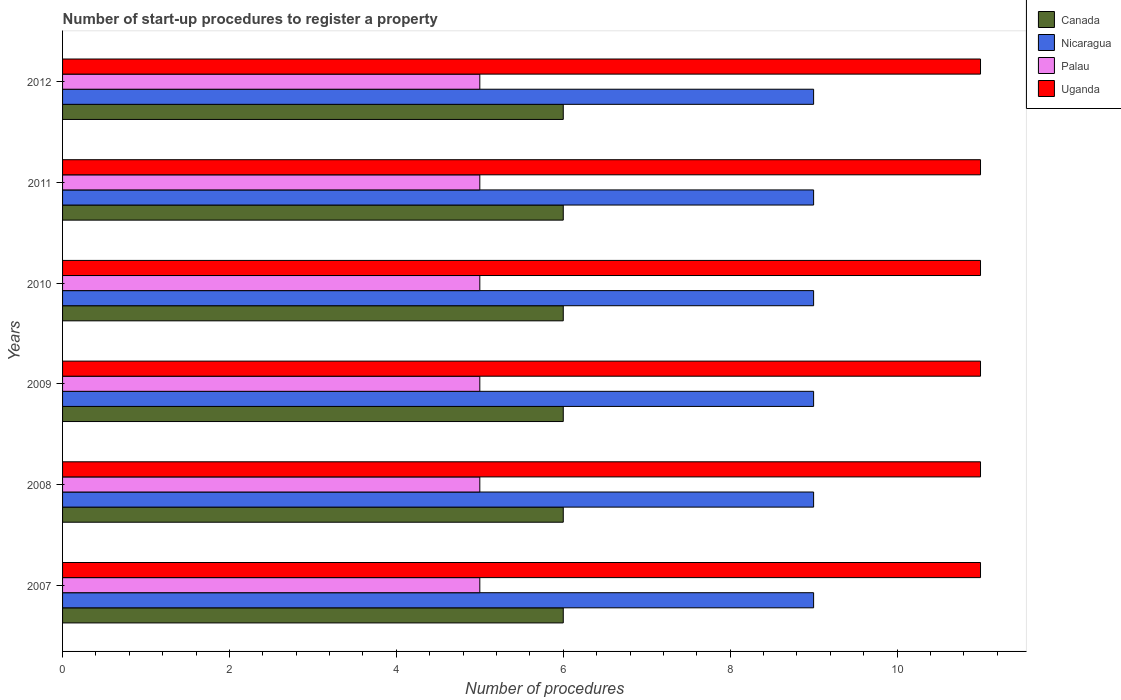How many groups of bars are there?
Ensure brevity in your answer.  6. How many bars are there on the 1st tick from the bottom?
Make the answer very short. 4. Across all years, what is the maximum number of procedures required to register a property in Canada?
Give a very brief answer. 6. Across all years, what is the minimum number of procedures required to register a property in Canada?
Ensure brevity in your answer.  6. In which year was the number of procedures required to register a property in Uganda maximum?
Offer a very short reply. 2007. What is the total number of procedures required to register a property in Palau in the graph?
Your answer should be compact. 30. What is the difference between the number of procedures required to register a property in Uganda in 2009 and that in 2011?
Your response must be concise. 0. What is the difference between the number of procedures required to register a property in Canada in 2009 and the number of procedures required to register a property in Nicaragua in 2007?
Your answer should be very brief. -3. What is the average number of procedures required to register a property in Canada per year?
Provide a short and direct response. 6. In the year 2010, what is the difference between the number of procedures required to register a property in Uganda and number of procedures required to register a property in Canada?
Provide a succinct answer. 5. In how many years, is the number of procedures required to register a property in Nicaragua greater than 4.8 ?
Your response must be concise. 6. What is the ratio of the number of procedures required to register a property in Nicaragua in 2007 to that in 2009?
Offer a very short reply. 1. Is the difference between the number of procedures required to register a property in Uganda in 2007 and 2008 greater than the difference between the number of procedures required to register a property in Canada in 2007 and 2008?
Your answer should be compact. No. What is the difference between the highest and the second highest number of procedures required to register a property in Canada?
Your answer should be very brief. 0. What is the difference between the highest and the lowest number of procedures required to register a property in Nicaragua?
Your answer should be compact. 0. In how many years, is the number of procedures required to register a property in Canada greater than the average number of procedures required to register a property in Canada taken over all years?
Make the answer very short. 0. Is the sum of the number of procedures required to register a property in Nicaragua in 2009 and 2012 greater than the maximum number of procedures required to register a property in Palau across all years?
Offer a terse response. Yes. What does the 4th bar from the bottom in 2012 represents?
Your answer should be compact. Uganda. Is it the case that in every year, the sum of the number of procedures required to register a property in Uganda and number of procedures required to register a property in Canada is greater than the number of procedures required to register a property in Palau?
Provide a succinct answer. Yes. How many years are there in the graph?
Keep it short and to the point. 6. Does the graph contain any zero values?
Make the answer very short. No. Does the graph contain grids?
Ensure brevity in your answer.  No. Where does the legend appear in the graph?
Your response must be concise. Top right. How many legend labels are there?
Ensure brevity in your answer.  4. How are the legend labels stacked?
Offer a very short reply. Vertical. What is the title of the graph?
Ensure brevity in your answer.  Number of start-up procedures to register a property. What is the label or title of the X-axis?
Give a very brief answer. Number of procedures. What is the Number of procedures of Nicaragua in 2007?
Make the answer very short. 9. What is the Number of procedures in Palau in 2007?
Provide a short and direct response. 5. What is the Number of procedures in Palau in 2008?
Provide a short and direct response. 5. What is the Number of procedures of Uganda in 2008?
Give a very brief answer. 11. What is the Number of procedures of Palau in 2009?
Give a very brief answer. 5. What is the Number of procedures of Canada in 2010?
Offer a terse response. 6. What is the Number of procedures of Palau in 2010?
Your response must be concise. 5. What is the Number of procedures in Palau in 2011?
Ensure brevity in your answer.  5. What is the Number of procedures in Uganda in 2011?
Make the answer very short. 11. What is the Number of procedures in Canada in 2012?
Keep it short and to the point. 6. What is the Number of procedures in Nicaragua in 2012?
Make the answer very short. 9. What is the Number of procedures of Uganda in 2012?
Your answer should be very brief. 11. Across all years, what is the maximum Number of procedures of Canada?
Provide a succinct answer. 6. Across all years, what is the maximum Number of procedures in Nicaragua?
Keep it short and to the point. 9. Across all years, what is the maximum Number of procedures of Palau?
Offer a terse response. 5. Across all years, what is the maximum Number of procedures in Uganda?
Your response must be concise. 11. Across all years, what is the minimum Number of procedures in Canada?
Offer a terse response. 6. Across all years, what is the minimum Number of procedures of Nicaragua?
Ensure brevity in your answer.  9. Across all years, what is the minimum Number of procedures in Palau?
Your answer should be compact. 5. Across all years, what is the minimum Number of procedures in Uganda?
Provide a short and direct response. 11. What is the total Number of procedures of Nicaragua in the graph?
Your response must be concise. 54. What is the difference between the Number of procedures of Canada in 2007 and that in 2008?
Ensure brevity in your answer.  0. What is the difference between the Number of procedures in Nicaragua in 2007 and that in 2008?
Provide a short and direct response. 0. What is the difference between the Number of procedures of Uganda in 2007 and that in 2008?
Your answer should be very brief. 0. What is the difference between the Number of procedures in Nicaragua in 2007 and that in 2009?
Make the answer very short. 0. What is the difference between the Number of procedures in Palau in 2007 and that in 2009?
Your answer should be compact. 0. What is the difference between the Number of procedures in Canada in 2007 and that in 2010?
Give a very brief answer. 0. What is the difference between the Number of procedures in Nicaragua in 2007 and that in 2010?
Provide a short and direct response. 0. What is the difference between the Number of procedures in Palau in 2007 and that in 2010?
Keep it short and to the point. 0. What is the difference between the Number of procedures of Uganda in 2007 and that in 2011?
Your answer should be very brief. 0. What is the difference between the Number of procedures of Nicaragua in 2007 and that in 2012?
Keep it short and to the point. 0. What is the difference between the Number of procedures in Nicaragua in 2008 and that in 2009?
Offer a very short reply. 0. What is the difference between the Number of procedures in Nicaragua in 2008 and that in 2010?
Ensure brevity in your answer.  0. What is the difference between the Number of procedures of Canada in 2008 and that in 2011?
Your answer should be very brief. 0. What is the difference between the Number of procedures of Nicaragua in 2008 and that in 2011?
Provide a short and direct response. 0. What is the difference between the Number of procedures of Uganda in 2008 and that in 2011?
Ensure brevity in your answer.  0. What is the difference between the Number of procedures of Canada in 2008 and that in 2012?
Provide a short and direct response. 0. What is the difference between the Number of procedures in Canada in 2009 and that in 2010?
Make the answer very short. 0. What is the difference between the Number of procedures of Palau in 2009 and that in 2010?
Offer a terse response. 0. What is the difference between the Number of procedures of Palau in 2009 and that in 2011?
Give a very brief answer. 0. What is the difference between the Number of procedures of Palau in 2009 and that in 2012?
Make the answer very short. 0. What is the difference between the Number of procedures in Uganda in 2009 and that in 2012?
Offer a very short reply. 0. What is the difference between the Number of procedures in Uganda in 2010 and that in 2011?
Your answer should be compact. 0. What is the difference between the Number of procedures of Canada in 2010 and that in 2012?
Your answer should be compact. 0. What is the difference between the Number of procedures in Nicaragua in 2010 and that in 2012?
Your answer should be very brief. 0. What is the difference between the Number of procedures in Palau in 2010 and that in 2012?
Your answer should be compact. 0. What is the difference between the Number of procedures in Uganda in 2010 and that in 2012?
Make the answer very short. 0. What is the difference between the Number of procedures of Canada in 2011 and that in 2012?
Keep it short and to the point. 0. What is the difference between the Number of procedures of Palau in 2011 and that in 2012?
Offer a very short reply. 0. What is the difference between the Number of procedures in Canada in 2007 and the Number of procedures in Nicaragua in 2008?
Your answer should be very brief. -3. What is the difference between the Number of procedures in Canada in 2007 and the Number of procedures in Palau in 2008?
Keep it short and to the point. 1. What is the difference between the Number of procedures in Palau in 2007 and the Number of procedures in Uganda in 2008?
Your response must be concise. -6. What is the difference between the Number of procedures of Canada in 2007 and the Number of procedures of Nicaragua in 2009?
Your answer should be compact. -3. What is the difference between the Number of procedures of Canada in 2007 and the Number of procedures of Palau in 2009?
Ensure brevity in your answer.  1. What is the difference between the Number of procedures of Canada in 2007 and the Number of procedures of Nicaragua in 2011?
Offer a very short reply. -3. What is the difference between the Number of procedures in Canada in 2007 and the Number of procedures in Palau in 2011?
Your response must be concise. 1. What is the difference between the Number of procedures of Nicaragua in 2007 and the Number of procedures of Palau in 2011?
Provide a succinct answer. 4. What is the difference between the Number of procedures of Canada in 2007 and the Number of procedures of Nicaragua in 2012?
Offer a very short reply. -3. What is the difference between the Number of procedures of Canada in 2007 and the Number of procedures of Palau in 2012?
Offer a terse response. 1. What is the difference between the Number of procedures in Canada in 2007 and the Number of procedures in Uganda in 2012?
Give a very brief answer. -5. What is the difference between the Number of procedures in Nicaragua in 2007 and the Number of procedures in Palau in 2012?
Keep it short and to the point. 4. What is the difference between the Number of procedures in Nicaragua in 2007 and the Number of procedures in Uganda in 2012?
Provide a succinct answer. -2. What is the difference between the Number of procedures of Palau in 2007 and the Number of procedures of Uganda in 2012?
Ensure brevity in your answer.  -6. What is the difference between the Number of procedures in Canada in 2008 and the Number of procedures in Nicaragua in 2009?
Ensure brevity in your answer.  -3. What is the difference between the Number of procedures in Canada in 2008 and the Number of procedures in Uganda in 2009?
Give a very brief answer. -5. What is the difference between the Number of procedures in Nicaragua in 2008 and the Number of procedures in Uganda in 2009?
Your response must be concise. -2. What is the difference between the Number of procedures in Palau in 2008 and the Number of procedures in Uganda in 2009?
Offer a terse response. -6. What is the difference between the Number of procedures of Canada in 2008 and the Number of procedures of Palau in 2010?
Make the answer very short. 1. What is the difference between the Number of procedures of Nicaragua in 2008 and the Number of procedures of Palau in 2010?
Ensure brevity in your answer.  4. What is the difference between the Number of procedures of Nicaragua in 2008 and the Number of procedures of Uganda in 2010?
Make the answer very short. -2. What is the difference between the Number of procedures in Palau in 2008 and the Number of procedures in Uganda in 2010?
Provide a succinct answer. -6. What is the difference between the Number of procedures in Canada in 2008 and the Number of procedures in Palau in 2011?
Give a very brief answer. 1. What is the difference between the Number of procedures in Canada in 2008 and the Number of procedures in Uganda in 2011?
Offer a terse response. -5. What is the difference between the Number of procedures in Canada in 2008 and the Number of procedures in Palau in 2012?
Provide a short and direct response. 1. What is the difference between the Number of procedures of Nicaragua in 2008 and the Number of procedures of Palau in 2012?
Your answer should be compact. 4. What is the difference between the Number of procedures in Palau in 2008 and the Number of procedures in Uganda in 2012?
Make the answer very short. -6. What is the difference between the Number of procedures in Canada in 2009 and the Number of procedures in Nicaragua in 2010?
Make the answer very short. -3. What is the difference between the Number of procedures of Nicaragua in 2009 and the Number of procedures of Palau in 2010?
Your answer should be very brief. 4. What is the difference between the Number of procedures of Nicaragua in 2009 and the Number of procedures of Uganda in 2010?
Provide a short and direct response. -2. What is the difference between the Number of procedures in Canada in 2009 and the Number of procedures in Nicaragua in 2011?
Your response must be concise. -3. What is the difference between the Number of procedures in Canada in 2009 and the Number of procedures in Palau in 2011?
Your answer should be very brief. 1. What is the difference between the Number of procedures of Palau in 2009 and the Number of procedures of Uganda in 2011?
Offer a very short reply. -6. What is the difference between the Number of procedures of Canada in 2009 and the Number of procedures of Nicaragua in 2012?
Your answer should be compact. -3. What is the difference between the Number of procedures of Canada in 2009 and the Number of procedures of Palau in 2012?
Your answer should be very brief. 1. What is the difference between the Number of procedures of Nicaragua in 2009 and the Number of procedures of Palau in 2012?
Ensure brevity in your answer.  4. What is the difference between the Number of procedures of Nicaragua in 2009 and the Number of procedures of Uganda in 2012?
Make the answer very short. -2. What is the difference between the Number of procedures in Palau in 2009 and the Number of procedures in Uganda in 2012?
Provide a short and direct response. -6. What is the difference between the Number of procedures of Canada in 2010 and the Number of procedures of Palau in 2011?
Make the answer very short. 1. What is the difference between the Number of procedures of Nicaragua in 2010 and the Number of procedures of Palau in 2011?
Provide a succinct answer. 4. What is the difference between the Number of procedures in Nicaragua in 2010 and the Number of procedures in Uganda in 2011?
Provide a succinct answer. -2. What is the difference between the Number of procedures of Palau in 2010 and the Number of procedures of Uganda in 2011?
Keep it short and to the point. -6. What is the difference between the Number of procedures in Nicaragua in 2010 and the Number of procedures in Uganda in 2012?
Ensure brevity in your answer.  -2. What is the difference between the Number of procedures in Canada in 2011 and the Number of procedures in Nicaragua in 2012?
Your response must be concise. -3. What is the difference between the Number of procedures in Canada in 2011 and the Number of procedures in Uganda in 2012?
Offer a very short reply. -5. What is the difference between the Number of procedures in Nicaragua in 2011 and the Number of procedures in Palau in 2012?
Your answer should be compact. 4. What is the difference between the Number of procedures in Palau in 2011 and the Number of procedures in Uganda in 2012?
Your response must be concise. -6. What is the average Number of procedures in Nicaragua per year?
Provide a short and direct response. 9. What is the average Number of procedures of Palau per year?
Your answer should be very brief. 5. In the year 2007, what is the difference between the Number of procedures in Canada and Number of procedures in Nicaragua?
Provide a succinct answer. -3. In the year 2007, what is the difference between the Number of procedures of Canada and Number of procedures of Palau?
Provide a succinct answer. 1. In the year 2007, what is the difference between the Number of procedures in Palau and Number of procedures in Uganda?
Provide a succinct answer. -6. In the year 2008, what is the difference between the Number of procedures in Canada and Number of procedures in Nicaragua?
Offer a terse response. -3. In the year 2008, what is the difference between the Number of procedures in Canada and Number of procedures in Uganda?
Your answer should be very brief. -5. In the year 2009, what is the difference between the Number of procedures in Nicaragua and Number of procedures in Uganda?
Provide a short and direct response. -2. In the year 2010, what is the difference between the Number of procedures of Canada and Number of procedures of Nicaragua?
Your answer should be compact. -3. In the year 2010, what is the difference between the Number of procedures in Nicaragua and Number of procedures in Uganda?
Keep it short and to the point. -2. In the year 2010, what is the difference between the Number of procedures of Palau and Number of procedures of Uganda?
Provide a short and direct response. -6. In the year 2011, what is the difference between the Number of procedures in Canada and Number of procedures in Palau?
Provide a succinct answer. 1. In the year 2011, what is the difference between the Number of procedures of Canada and Number of procedures of Uganda?
Your answer should be very brief. -5. In the year 2011, what is the difference between the Number of procedures of Nicaragua and Number of procedures of Uganda?
Offer a very short reply. -2. In the year 2011, what is the difference between the Number of procedures of Palau and Number of procedures of Uganda?
Provide a short and direct response. -6. In the year 2012, what is the difference between the Number of procedures in Canada and Number of procedures in Uganda?
Your answer should be very brief. -5. In the year 2012, what is the difference between the Number of procedures in Nicaragua and Number of procedures in Uganda?
Ensure brevity in your answer.  -2. What is the ratio of the Number of procedures of Palau in 2007 to that in 2008?
Provide a succinct answer. 1. What is the ratio of the Number of procedures of Uganda in 2007 to that in 2008?
Ensure brevity in your answer.  1. What is the ratio of the Number of procedures of Canada in 2007 to that in 2009?
Keep it short and to the point. 1. What is the ratio of the Number of procedures of Palau in 2007 to that in 2009?
Your answer should be very brief. 1. What is the ratio of the Number of procedures of Uganda in 2007 to that in 2009?
Your response must be concise. 1. What is the ratio of the Number of procedures of Canada in 2007 to that in 2010?
Keep it short and to the point. 1. What is the ratio of the Number of procedures in Nicaragua in 2007 to that in 2010?
Give a very brief answer. 1. What is the ratio of the Number of procedures in Canada in 2007 to that in 2011?
Keep it short and to the point. 1. What is the ratio of the Number of procedures of Nicaragua in 2007 to that in 2011?
Your response must be concise. 1. What is the ratio of the Number of procedures of Palau in 2007 to that in 2011?
Make the answer very short. 1. What is the ratio of the Number of procedures of Palau in 2008 to that in 2009?
Offer a terse response. 1. What is the ratio of the Number of procedures of Uganda in 2008 to that in 2009?
Provide a succinct answer. 1. What is the ratio of the Number of procedures of Canada in 2008 to that in 2010?
Offer a terse response. 1. What is the ratio of the Number of procedures of Palau in 2008 to that in 2010?
Your answer should be compact. 1. What is the ratio of the Number of procedures in Uganda in 2008 to that in 2010?
Your response must be concise. 1. What is the ratio of the Number of procedures of Canada in 2008 to that in 2011?
Your response must be concise. 1. What is the ratio of the Number of procedures of Nicaragua in 2008 to that in 2011?
Ensure brevity in your answer.  1. What is the ratio of the Number of procedures of Uganda in 2008 to that in 2011?
Provide a succinct answer. 1. What is the ratio of the Number of procedures of Canada in 2008 to that in 2012?
Offer a terse response. 1. What is the ratio of the Number of procedures in Palau in 2008 to that in 2012?
Make the answer very short. 1. What is the ratio of the Number of procedures in Uganda in 2008 to that in 2012?
Your response must be concise. 1. What is the ratio of the Number of procedures in Canada in 2009 to that in 2010?
Keep it short and to the point. 1. What is the ratio of the Number of procedures of Palau in 2009 to that in 2011?
Your response must be concise. 1. What is the ratio of the Number of procedures of Uganda in 2009 to that in 2011?
Provide a short and direct response. 1. What is the ratio of the Number of procedures of Palau in 2009 to that in 2012?
Your response must be concise. 1. What is the ratio of the Number of procedures in Canada in 2010 to that in 2011?
Provide a succinct answer. 1. What is the ratio of the Number of procedures in Uganda in 2010 to that in 2011?
Provide a succinct answer. 1. What is the ratio of the Number of procedures in Palau in 2010 to that in 2012?
Make the answer very short. 1. What is the ratio of the Number of procedures of Nicaragua in 2011 to that in 2012?
Provide a succinct answer. 1. What is the difference between the highest and the second highest Number of procedures of Canada?
Make the answer very short. 0. What is the difference between the highest and the second highest Number of procedures of Nicaragua?
Provide a succinct answer. 0. What is the difference between the highest and the second highest Number of procedures in Palau?
Your answer should be very brief. 0. What is the difference between the highest and the lowest Number of procedures of Canada?
Ensure brevity in your answer.  0. What is the difference between the highest and the lowest Number of procedures of Palau?
Keep it short and to the point. 0. 